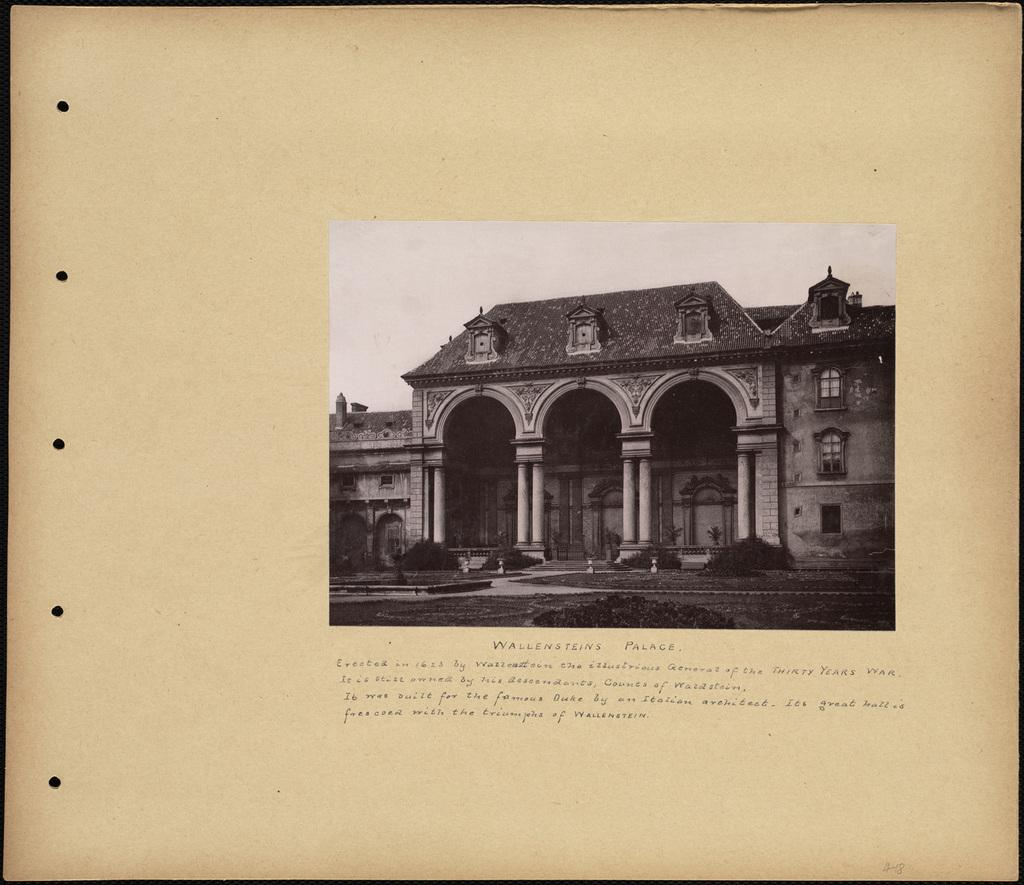What is the medium of the image? The image is on a paper. What is depicted in the image on the paper? There is a picture of a building on the paper. Is there any text accompanying the image? Yes, there is writing under the picture. How many frogs can be seen sitting on the lace in the image? There are no frogs or lace present in the image; it features a picture of a building with writing underneath. 